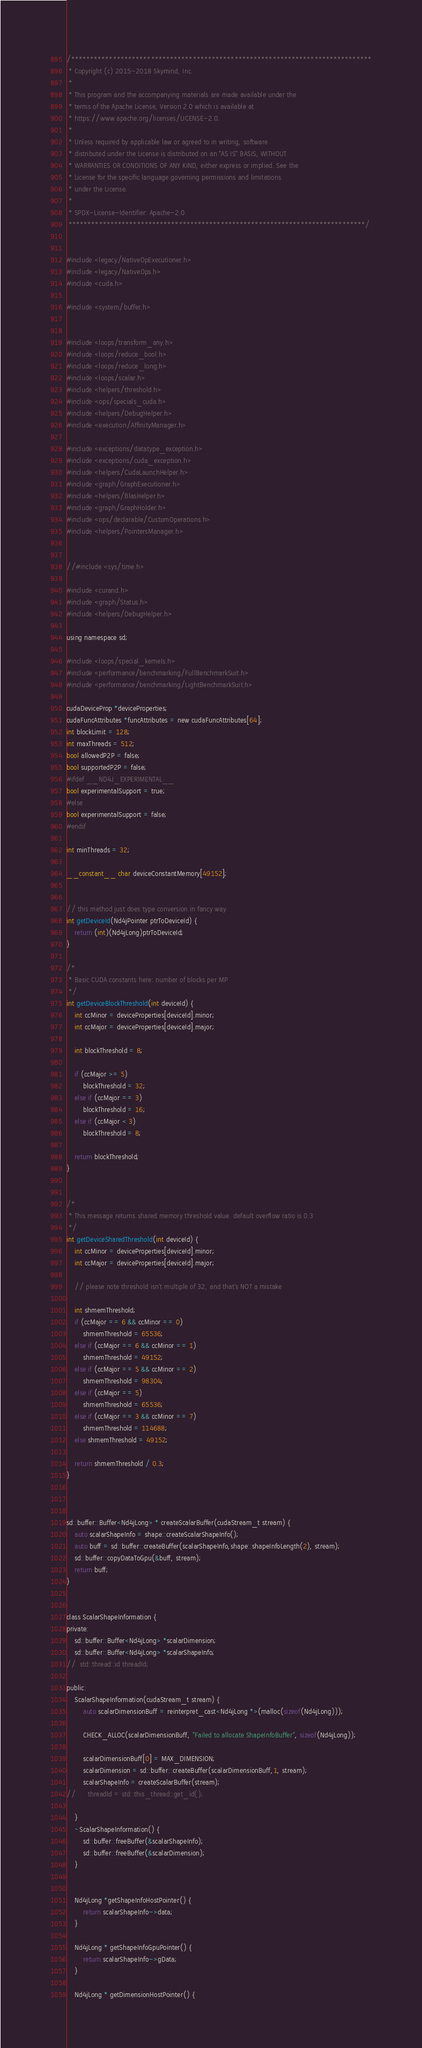<code> <loc_0><loc_0><loc_500><loc_500><_Cuda_>/*******************************************************************************
 * Copyright (c) 2015-2018 Skymind, Inc.
 *
 * This program and the accompanying materials are made available under the
 * terms of the Apache License, Version 2.0 which is available at
 * https://www.apache.org/licenses/LICENSE-2.0.
 *
 * Unless required by applicable law or agreed to in writing, software
 * distributed under the License is distributed on an "AS IS" BASIS, WITHOUT
 * WARRANTIES OR CONDITIONS OF ANY KIND, either express or implied. See the
 * License for the specific language governing permissions and limitations
 * under the License.
 *
 * SPDX-License-Identifier: Apache-2.0
 ******************************************************************************/


#include <legacy/NativeOpExecutioner.h>
#include <legacy/NativeOps.h>
#include <cuda.h>

#include <system/buffer.h>


#include <loops/transform_any.h>
#include <loops/reduce_bool.h>
#include <loops/reduce_long.h>
#include <loops/scalar.h>
#include <helpers/threshold.h>
#include <ops/specials_cuda.h>
#include <helpers/DebugHelper.h>
#include <execution/AffinityManager.h>

#include <exceptions/datatype_exception.h>
#include <exceptions/cuda_exception.h>
#include <helpers/CudaLaunchHelper.h>
#include <graph/GraphExecutioner.h>
#include <helpers/BlasHelper.h>
#include <graph/GraphHolder.h>
#include <ops/declarable/CustomOperations.h>
#include <helpers/PointersManager.h>


//#include <sys/time.h>

#include <curand.h>
#include <graph/Status.h>
#include <helpers/DebugHelper.h>

using namespace sd;

#include <loops/special_kernels.h>
#include <performance/benchmarking/FullBenchmarkSuit.h>
#include <performance/benchmarking/LightBenchmarkSuit.h>

cudaDeviceProp *deviceProperties;
cudaFuncAttributes *funcAttributes = new cudaFuncAttributes[64];
int blockLimit = 128;
int maxThreads = 512;
bool allowedP2P = false;
bool supportedP2P = false;
#ifdef __ND4J_EXPERIMENTAL__
bool experimentalSupport = true;
#else
bool experimentalSupport = false;
#endif

int minThreads = 32;

__constant__ char deviceConstantMemory[49152];


// this method just does type conversion in fancy way
int getDeviceId(Nd4jPointer ptrToDeviceId) {
    return (int)(Nd4jLong)ptrToDeviceId;
}

/*
 * Basic CUDA constants here: number of blocks per MP
 */
int getDeviceBlockThreshold(int deviceId) {
	int ccMinor = deviceProperties[deviceId].minor;
	int ccMajor = deviceProperties[deviceId].major;

	int blockThreshold = 8;

	if (ccMajor >= 5)
		blockThreshold = 32;
	else if (ccMajor == 3)
		blockThreshold = 16;
	else if (ccMajor < 3)
		blockThreshold = 8;

	return blockThreshold;
}


/*
 * This message returns shared memory threshold value. default overflow ratio is 0.3
 */
int getDeviceSharedThreshold(int deviceId) {
	int ccMinor = deviceProperties[deviceId].minor;
	int ccMajor = deviceProperties[deviceId].major;

	// please note threshold isn't multiple of 32, and that's NOT a mistake

	int shmemThreshold;
	if (ccMajor == 6 && ccMinor == 0)
		shmemThreshold = 65536;
	else if (ccMajor == 6 && ccMinor == 1)
		shmemThreshold = 49152;
	else if (ccMajor == 5 && ccMinor == 2)
		shmemThreshold = 98304;
	else if (ccMajor == 5)
		shmemThreshold = 65536;
	else if (ccMajor == 3 && ccMinor == 7)
		shmemThreshold = 114688;
	else shmemThreshold = 49152;

	return shmemThreshold / 0.3;
}



sd::buffer::Buffer<Nd4jLong> * createScalarBuffer(cudaStream_t stream) {
	auto scalarShapeInfo = shape::createScalarShapeInfo();
	auto buff = sd::buffer::createBuffer(scalarShapeInfo,shape::shapeInfoLength(2), stream);
	sd::buffer::copyDataToGpu(&buff, stream);
	return buff;
}


class ScalarShapeInformation {
private:
	sd::buffer::Buffer<Nd4jLong> *scalarDimension;
	sd::buffer::Buffer<Nd4jLong> *scalarShapeInfo;
//	std::thread::id threadId;

public:
	ScalarShapeInformation(cudaStream_t stream) {
		auto scalarDimensionBuff = reinterpret_cast<Nd4jLong *>(malloc(sizeof(Nd4jLong)));

		CHECK_ALLOC(scalarDimensionBuff, "Failed to allocate ShapeInfoBuffer", sizeof(Nd4jLong));

		scalarDimensionBuff[0] = MAX_DIMENSION;
		scalarDimension = sd::buffer::createBuffer(scalarDimensionBuff,1, stream);
		scalarShapeInfo = createScalarBuffer(stream);
//		threadId = std::this_thread::get_id();

	}
	~ScalarShapeInformation() {
		sd::buffer::freeBuffer(&scalarShapeInfo);
		sd::buffer::freeBuffer(&scalarDimension);
	}


	Nd4jLong *getShapeInfoHostPointer() {
		return scalarShapeInfo->data;
	}

	Nd4jLong * getShapeInfoGpuPointer() {
		return scalarShapeInfo->gData;
	}

	Nd4jLong * getDimensionHostPointer() {</code> 